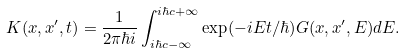Convert formula to latex. <formula><loc_0><loc_0><loc_500><loc_500>K ( x , x ^ { \prime } , t ) = \frac { 1 } { 2 \pi \hbar { i } } \int ^ { i \hbar { c } + \infty } _ { i \hbar { c } - \infty } \exp ( - i E t / \hbar { ) } G ( x , x ^ { \prime } , E ) d E .</formula> 